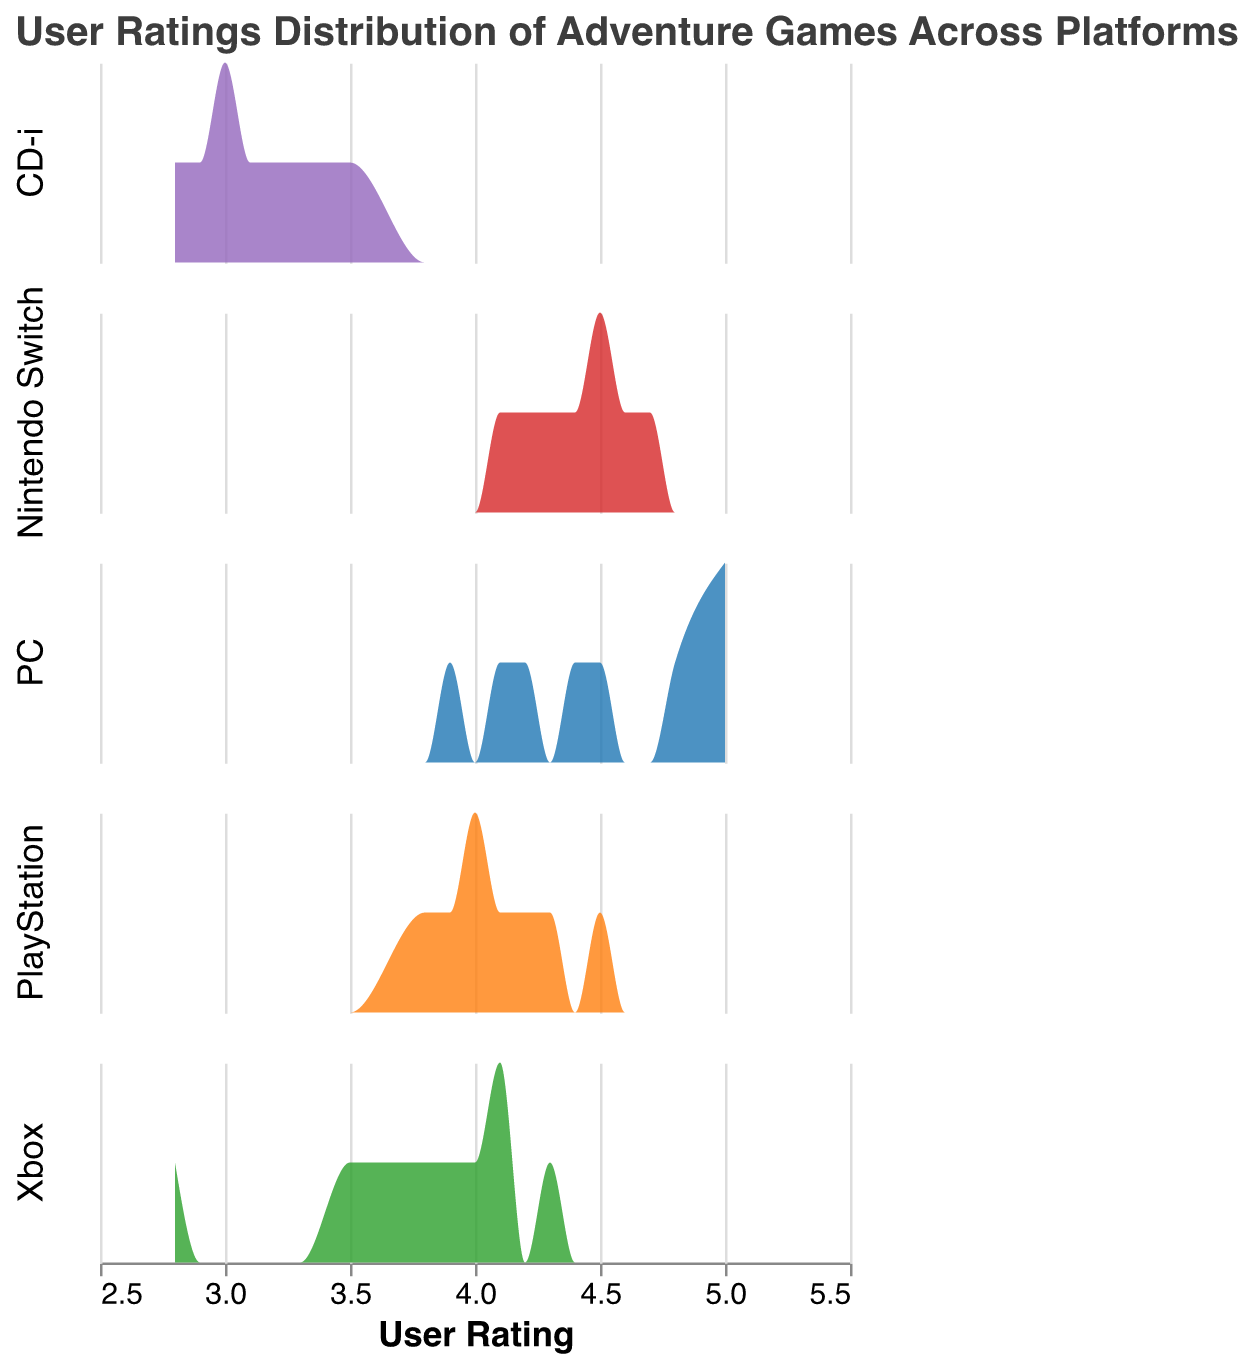What's the title of the figure? The title of the figure is displayed at the top and reads "User Ratings Distribution of Adventure Games Across Platforms."
Answer: User Ratings Distribution of Adventure Games Across Platforms What platforms are included in the figure? The platforms are listed in the figure's legends and subplots. They are PC, PlayStation, Xbox, Nintendo Switch, and CD-i.
Answer: PC, PlayStation, Xbox, Nintendo Switch, CD-i Which platform has the highest density of user ratings around the value 5? The PC subplot shows a noticeable peak around the rating value of 5, indicating that PC has the highest density of user ratings around the value of 5.
Answer: PC Which platform showcases the most varied range of user ratings? By observing the spread of the density plots, Xbox showcases the most varied range of user ratings, with values spanning from 2.8 to 4.3.
Answer: Xbox What common trend can be observed in the user ratings of Nintendo Switch adventure games? The density plot for Nintendo Switch adventure games is skewed towards higher ratings, showing that most ratings are between 4.0 and 4.7.
Answer: Skewed towards higher ratings How do the distributions of user ratings for PC and PlayStation compare? PC has a higher peak around 5.0, while PlayStation's ratings are more moderately distributed, peaking around 4.0 and 4.2. This shows that the PC ratings are higher on average than PlayStation's.
Answer: PC ratings are higher on average than PlayStation's Between CD-i and Xbox, which platform has more user ratings below 4? CD-i has more user ratings below 4, with a significant concentration of ratings around 2.8 to 3.5, while Xbox spans wider but also has multiple ratings below 4.
Answer: CD-i What can be inferred about the average rating for adventure games on the CD-i platform compared to the other platforms? The CD-i's density plot has its peak around 3.0 to 3.3, which is lower compared to the peaks of the other platforms like Nintendo Switch, PlayStation, and PC, indicating a lower average rating for CD-i.
Answer: Lower average rating What is the color used to represent the PlayStation platform in the density plot? By referring to the color legend, the PlayStation platform is represented using an orange color in the density plot.
Answer: Orange If a user gives an adventure game a 4.5 rating, which platforms could this rating belong to based on the density plots? Based on the density plots, a 4.5 rating could belong to adventure games on the PC, PlayStation, or Nintendo Switch platforms where such ratings are present.
Answer: PC, PlayStation, Nintendo Switch 